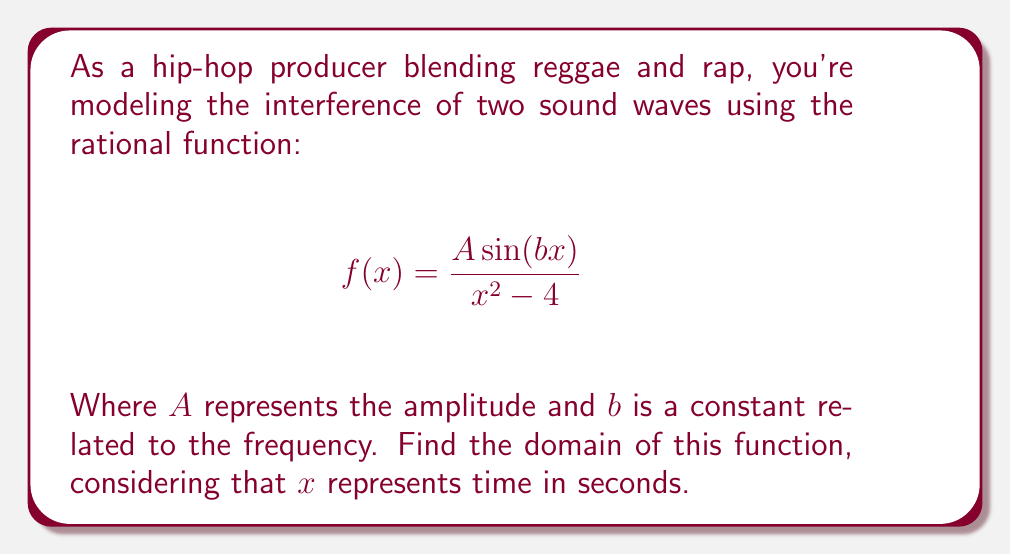Solve this math problem. To find the domain of this rational function, we need to consider two factors:

1) The denominator cannot be zero.
2) The function is defined for all other real numbers.

Step 1: Set the denominator equal to zero and solve for x.
$$x^2 - 4 = 0$$
$$x^2 = 4$$
$$x = \pm 2$$

Step 2: The function is undefined when $x = 2$ or $x = -2$.

Step 3: The numerator, $A \sin(bx)$, is defined for all real numbers, so it doesn't impose any additional restrictions on the domain.

Step 4: Express the domain in interval notation. The domain includes all real numbers except for 2 and -2.

Therefore, the domain is: $(-\infty, -2) \cup (-2, 2) \cup (2, \infty)$

This means the function is defined for all time values except at exactly 2 seconds before and after the reference point (x = 0).
Answer: $(-\infty, -2) \cup (-2, 2) \cup (2, \infty)$ 